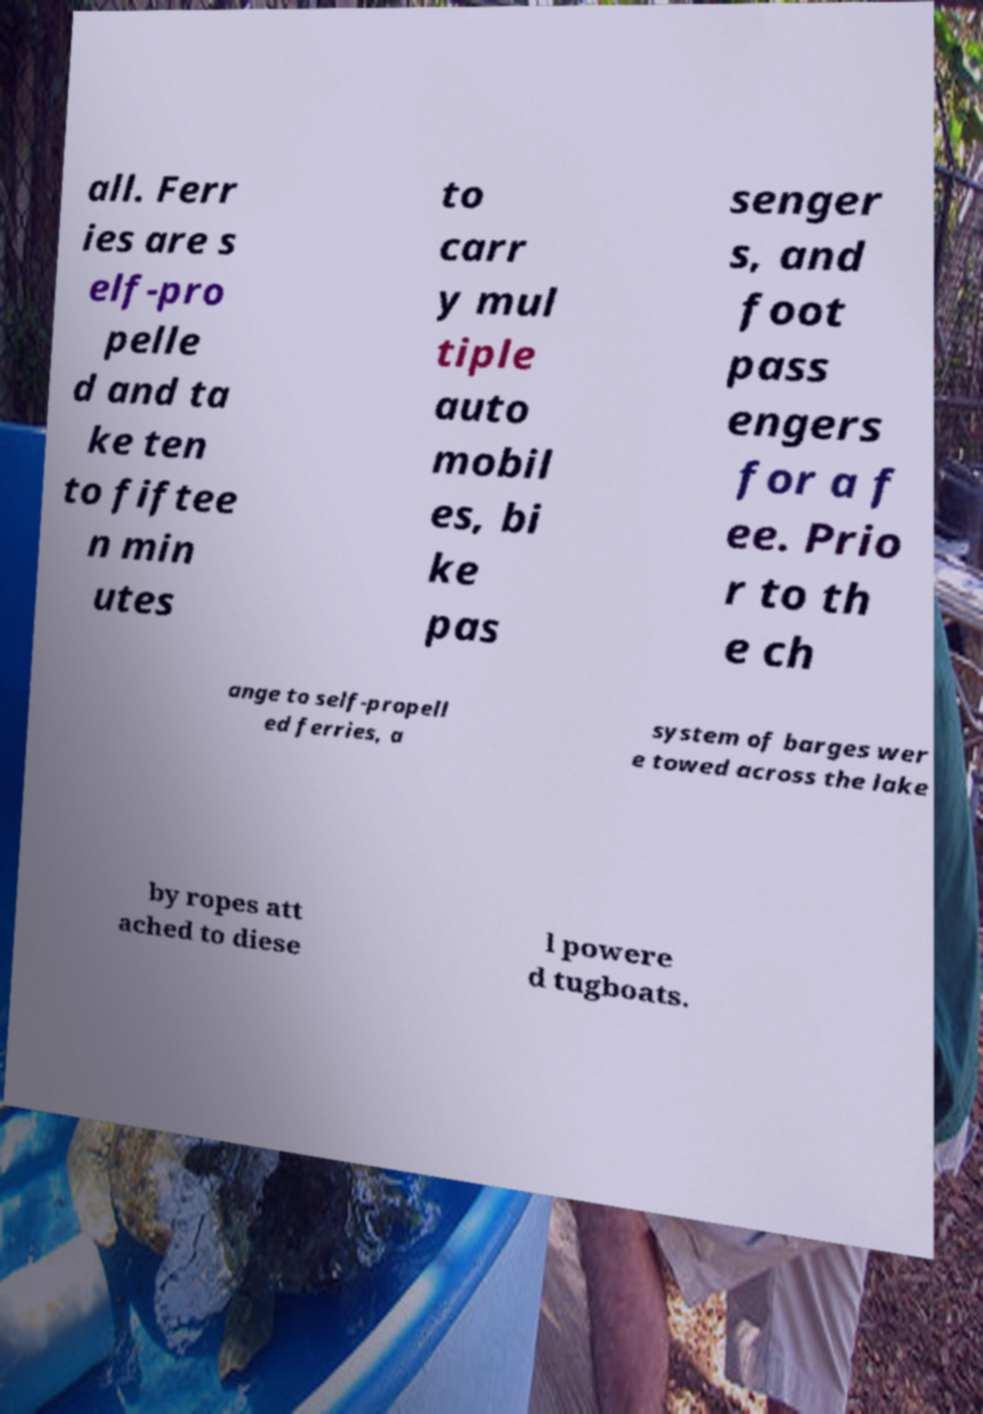Could you assist in decoding the text presented in this image and type it out clearly? all. Ferr ies are s elf-pro pelle d and ta ke ten to fiftee n min utes to carr y mul tiple auto mobil es, bi ke pas senger s, and foot pass engers for a f ee. Prio r to th e ch ange to self-propell ed ferries, a system of barges wer e towed across the lake by ropes att ached to diese l powere d tugboats. 